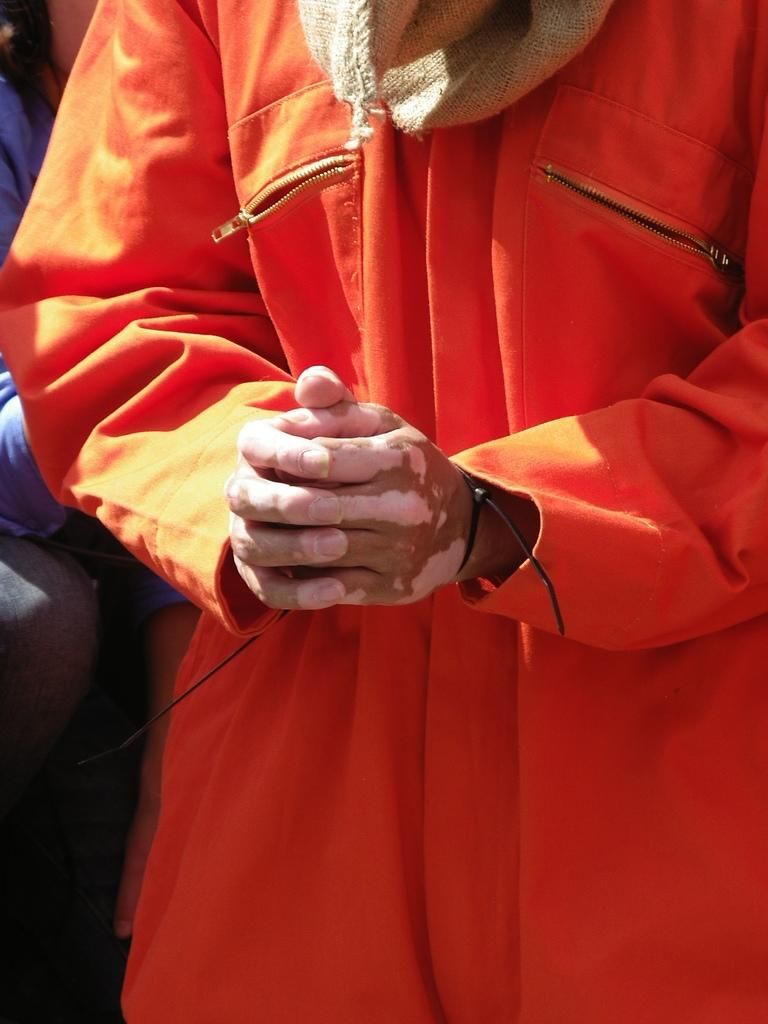What is the main subject of the image? There is a person standing in the image. What is the person wearing? The person is wearing a jacket. Can you describe any accessories the person is wearing? There is a band around the person's wrist. Are there any other people visible in the image? Yes, there are other people visible behind the person. What type of event is taking place in the image? There is no specific event mentioned or depicted in the image. How many houses are visible in the image? There are no houses visible in the image. 